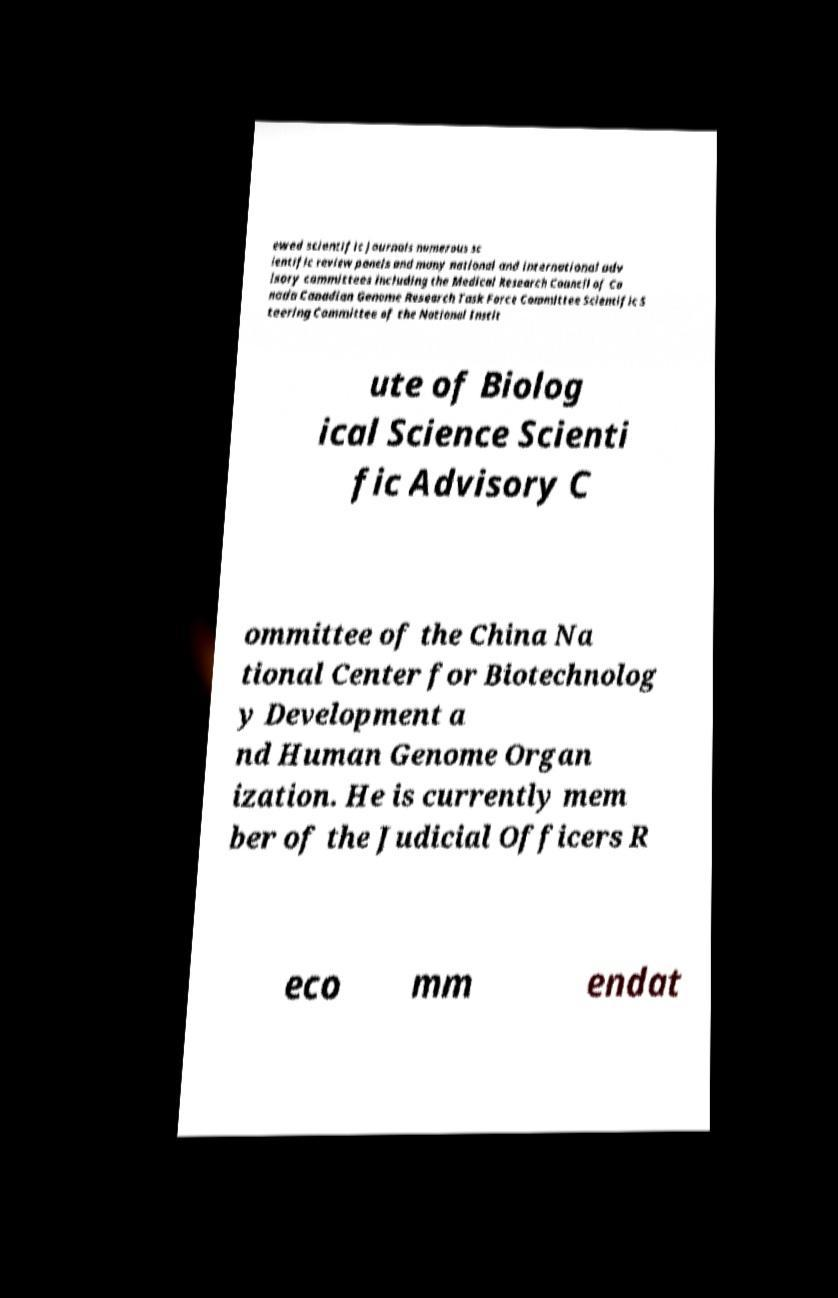Please identify and transcribe the text found in this image. ewed scientific journals numerous sc ientific review panels and many national and international adv isory committees including the Medical Research Council of Ca nada Canadian Genome Research Task Force Committee Scientific S teering Committee of the National Instit ute of Biolog ical Science Scienti fic Advisory C ommittee of the China Na tional Center for Biotechnolog y Development a nd Human Genome Organ ization. He is currently mem ber of the Judicial Officers R eco mm endat 